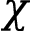<formula> <loc_0><loc_0><loc_500><loc_500>\chi</formula> 